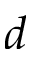<formula> <loc_0><loc_0><loc_500><loc_500>d</formula> 